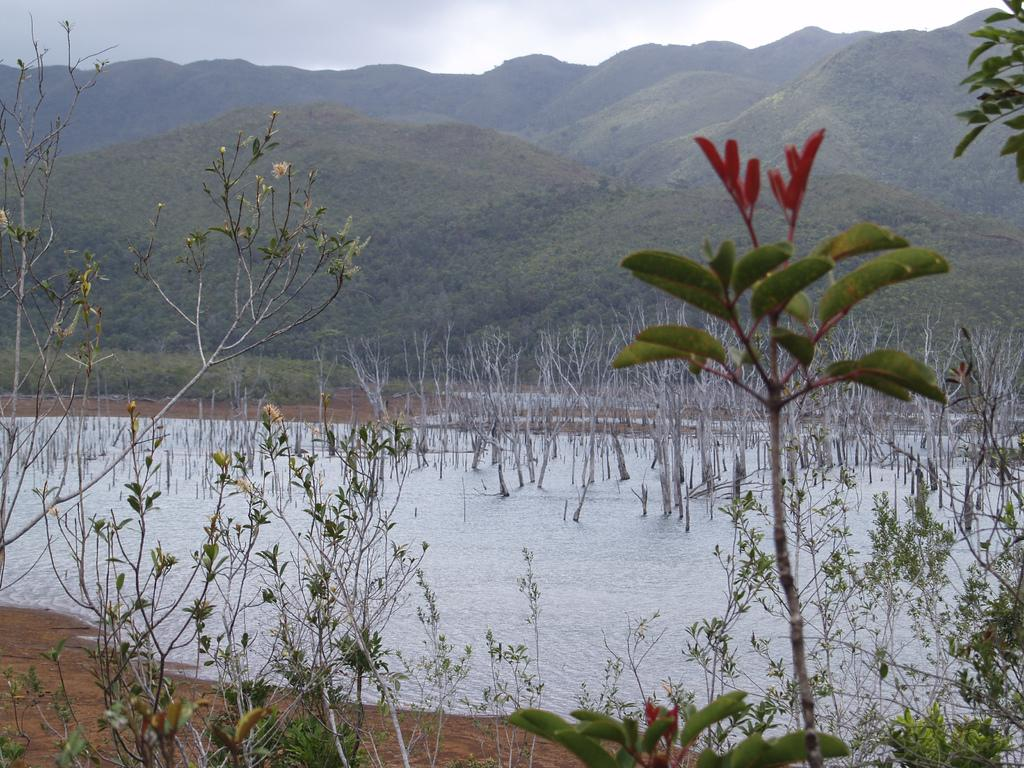What type of living organisms can be seen in the image? Plants can be seen in the image. What is the water surface like in the image? There is a water surface with streams in the image. What can be seen in the distance in the image? Mountains are visible in the background of the image. What else is visible in the background of the image? The sky is visible in the background of the image. What shape is the dock in the image? There is no dock present in the image. How does the water smash against the rocks in the image? The image does not show the water smashing against rocks; it only shows streams on a water surface. 